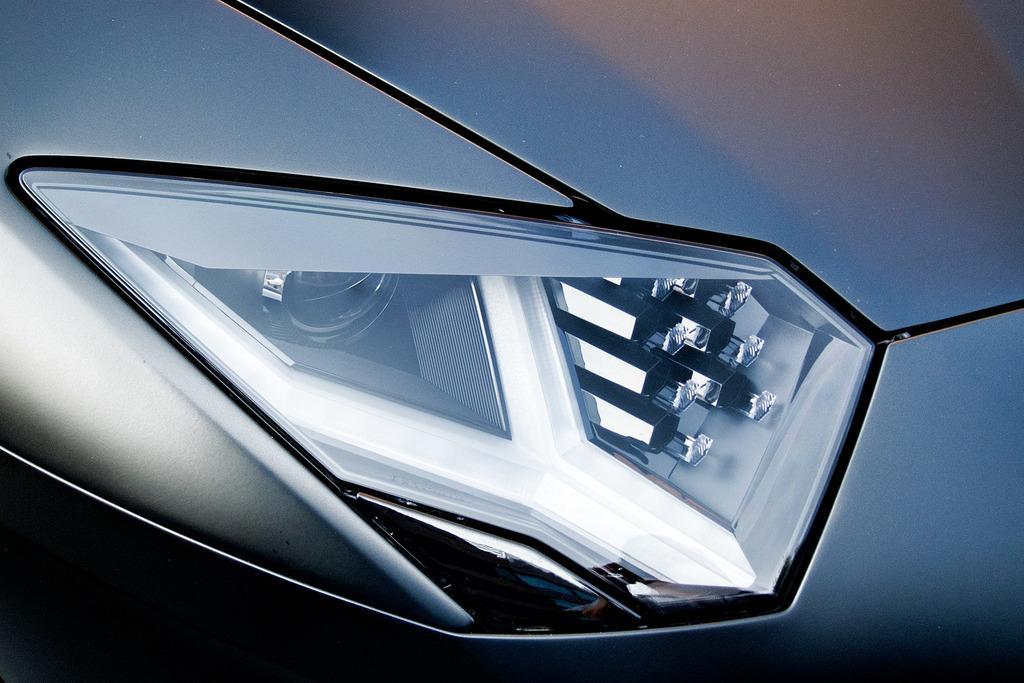Can you describe this image briefly? In this image I can see headlight of a vehicle in the front. 